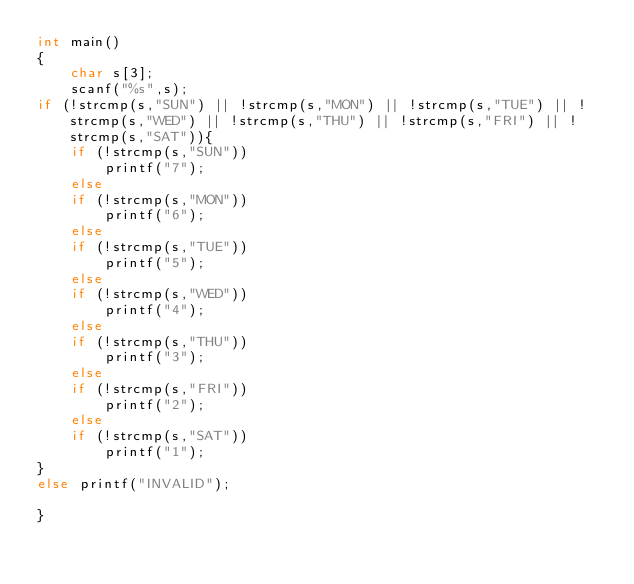Convert code to text. <code><loc_0><loc_0><loc_500><loc_500><_C_>int main()
{
    char s[3];
    scanf("%s",s);
if (!strcmp(s,"SUN") || !strcmp(s,"MON") || !strcmp(s,"TUE") || !strcmp(s,"WED") || !strcmp(s,"THU") || !strcmp(s,"FRI") || !strcmp(s,"SAT")){
    if (!strcmp(s,"SUN"))
        printf("7");
    else
    if (!strcmp(s,"MON"))
        printf("6");
    else
    if (!strcmp(s,"TUE"))
        printf("5");
    else
    if (!strcmp(s,"WED"))
        printf("4");
    else
    if (!strcmp(s,"THU"))
        printf("3");
    else
    if (!strcmp(s,"FRI"))
        printf("2");
    else
    if (!strcmp(s,"SAT"))
        printf("1");
}
else printf("INVALID");

}
</code> 